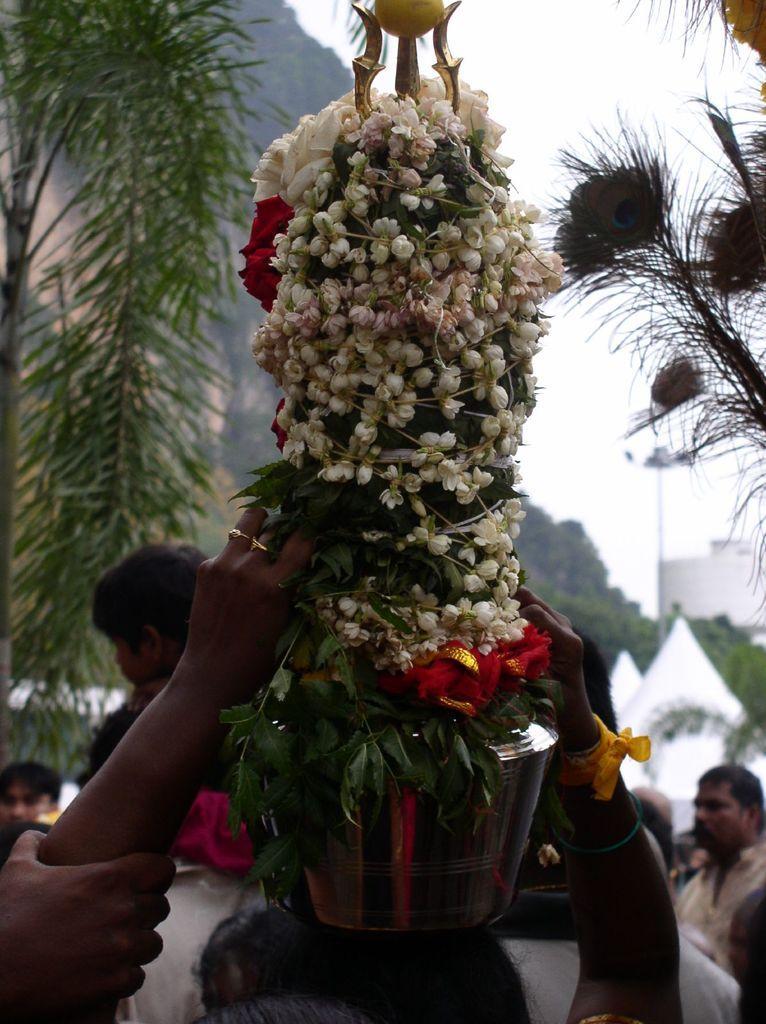How would you summarize this image in a sentence or two? This image is taken outdoors. At the top of the image there is the sky. In the background there are a few trees. There is a pole with a street light. On the left side of the image there is a tree. On the right side of the image there are a few peacock feathers. There is a house. In the middle of the image a woman is standing and she is holding a pot with many flowers on her head and a few people are standing on the ground. 